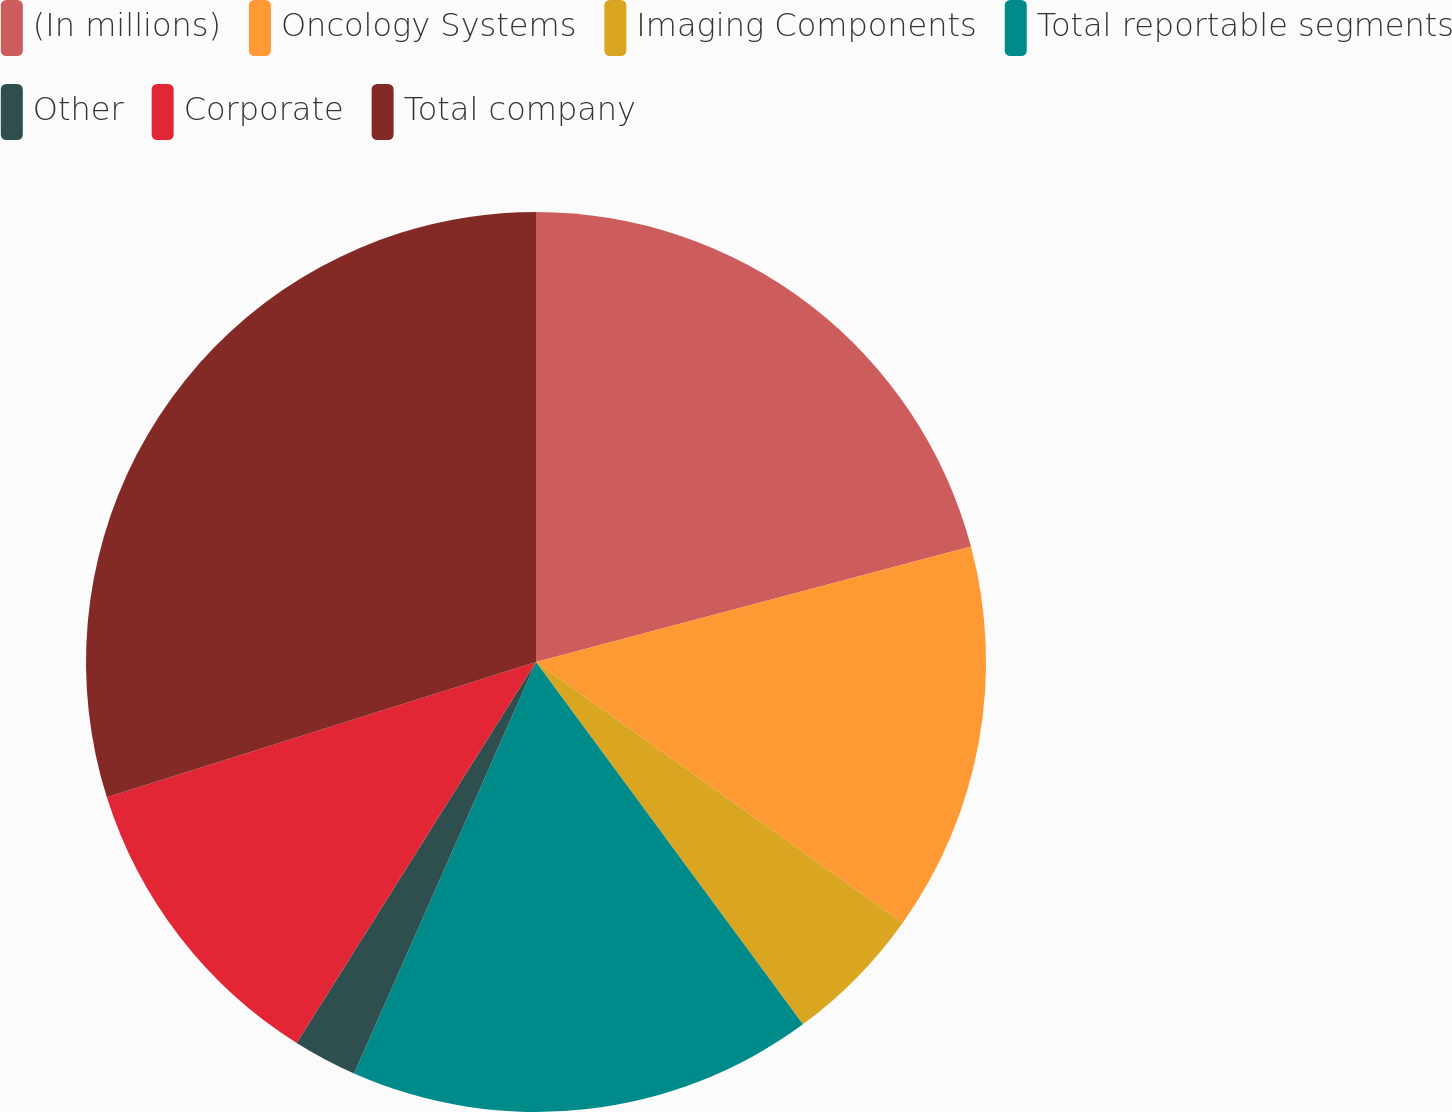Convert chart. <chart><loc_0><loc_0><loc_500><loc_500><pie_chart><fcel>(In millions)<fcel>Oncology Systems<fcel>Imaging Components<fcel>Total reportable segments<fcel>Other<fcel>Corporate<fcel>Total company<nl><fcel>20.87%<fcel>13.97%<fcel>5.05%<fcel>16.73%<fcel>2.3%<fcel>11.21%<fcel>29.86%<nl></chart> 